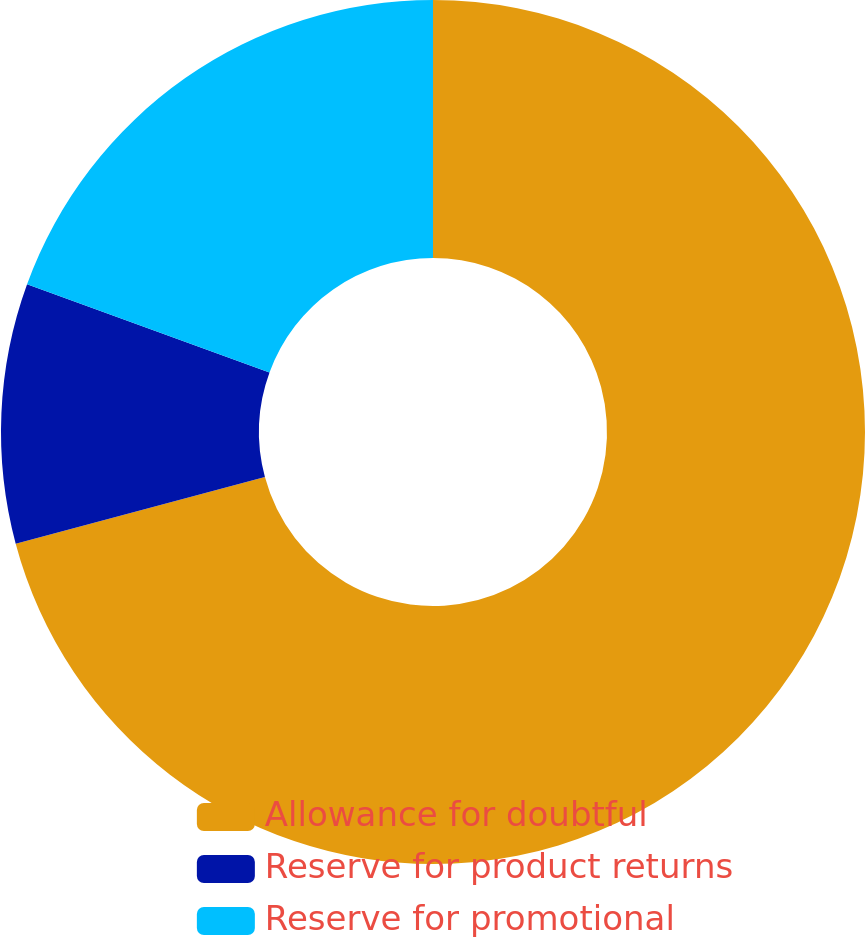Convert chart. <chart><loc_0><loc_0><loc_500><loc_500><pie_chart><fcel>Allowance for doubtful<fcel>Reserve for product returns<fcel>Reserve for promotional<nl><fcel>70.83%<fcel>9.72%<fcel>19.44%<nl></chart> 